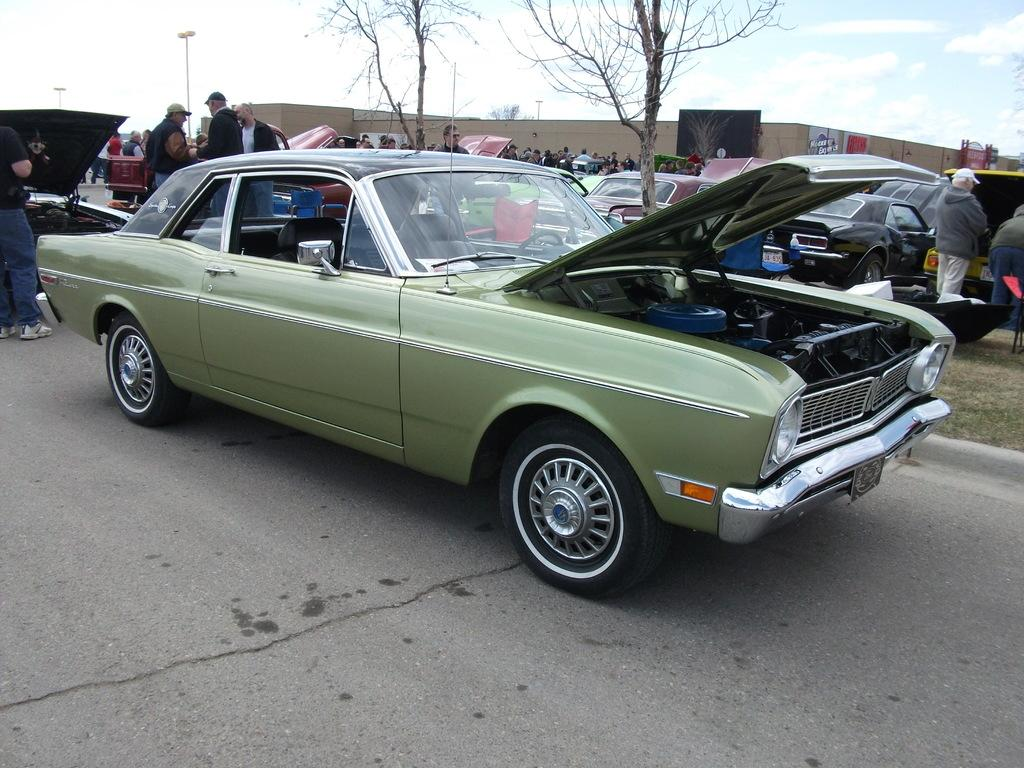What is the main subject in the center of the image? There is a car in the center of the image. What can be seen in the background of the image? In the background of the image, there are cars, people, posters, poles, and trees. How many cars are visible in the image? There is one car in the center and at least one car in the background, so there are at least two cars visible in the image. What type of meal is being prepared in the car's trunk in the image? There is no meal or any indication of food preparation in the image; it primarily features cars and their surroundings. 